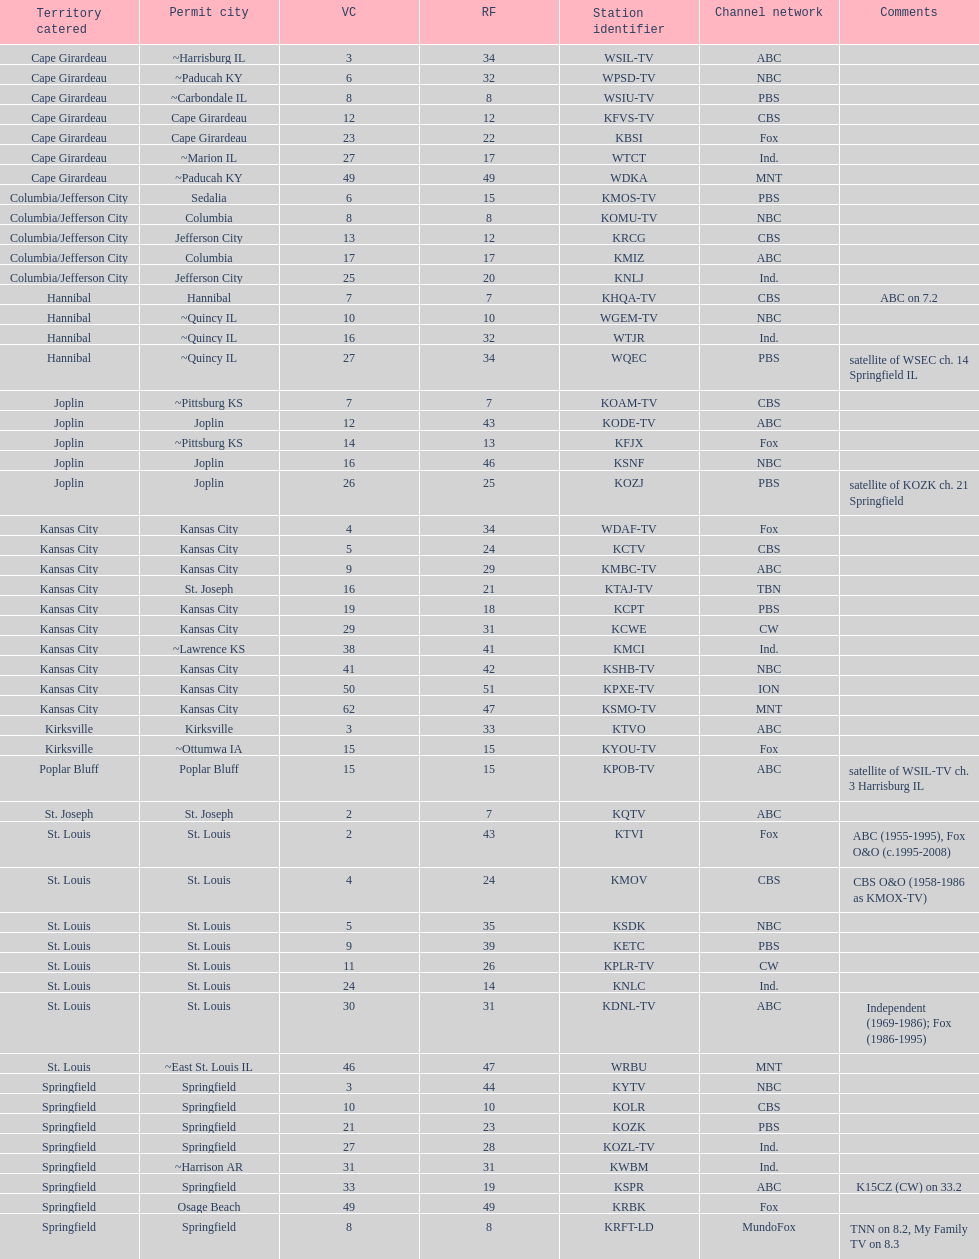How many tv channels are available in the cape girardeau area? 7. 